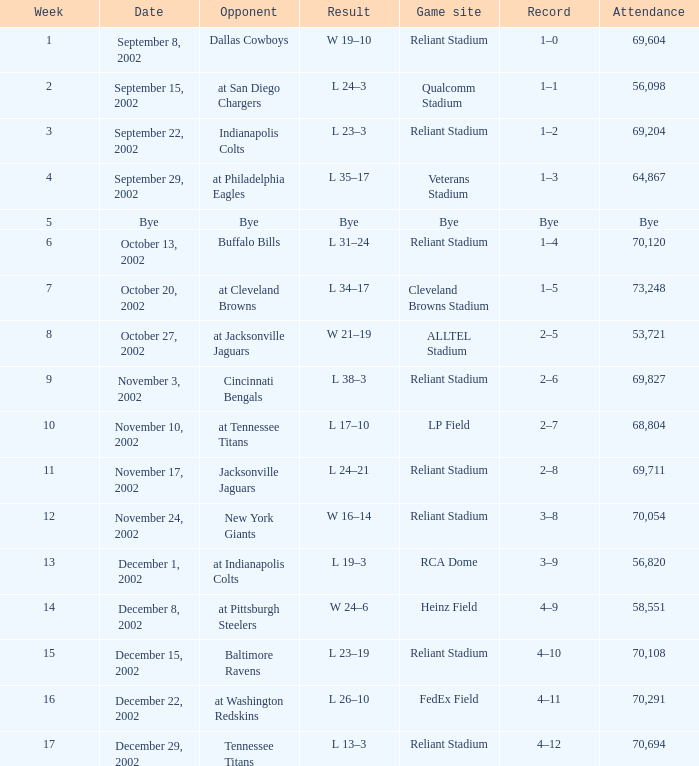When did the texans compete at lp field? November 10, 2002. 